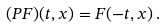<formula> <loc_0><loc_0><loc_500><loc_500>( P F ) ( t , x ) = F ( - t , x ) \, .</formula> 